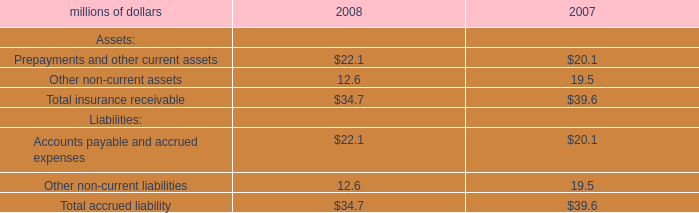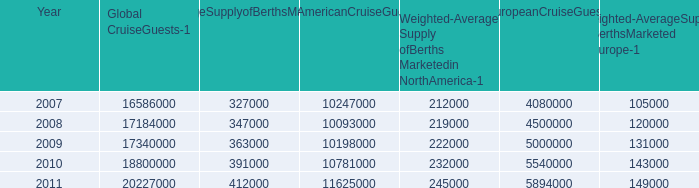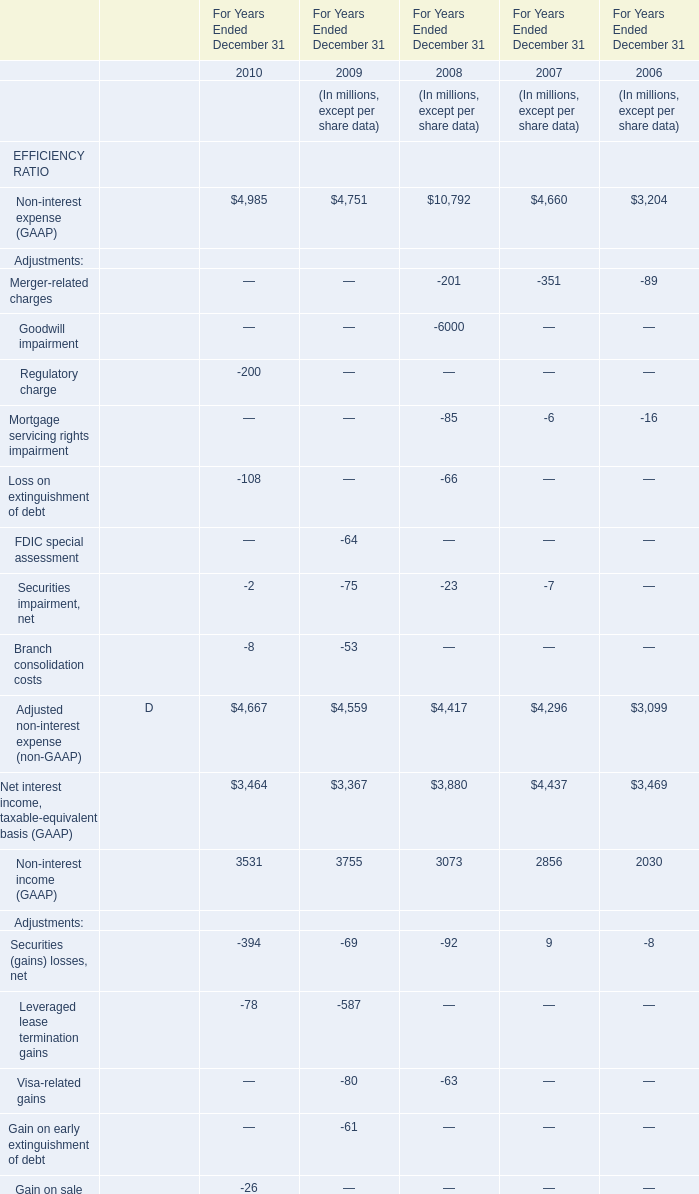what is the annual average of berths per ship , from 2012-2016 , that are expected to be placed in service in the north american cruise market? 
Computations: ((34000 / 10) / 4)
Answer: 850.0. 